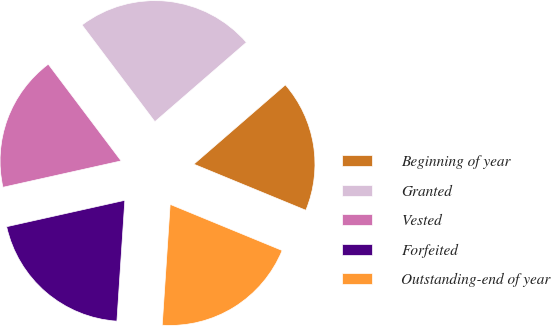<chart> <loc_0><loc_0><loc_500><loc_500><pie_chart><fcel>Beginning of year<fcel>Granted<fcel>Vested<fcel>Forfeited<fcel>Outstanding-end of year<nl><fcel>17.58%<fcel>23.91%<fcel>18.22%<fcel>20.46%<fcel>19.83%<nl></chart> 